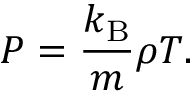Convert formula to latex. <formula><loc_0><loc_0><loc_500><loc_500>P = \frac { k _ { B } } { m } \rho T .</formula> 